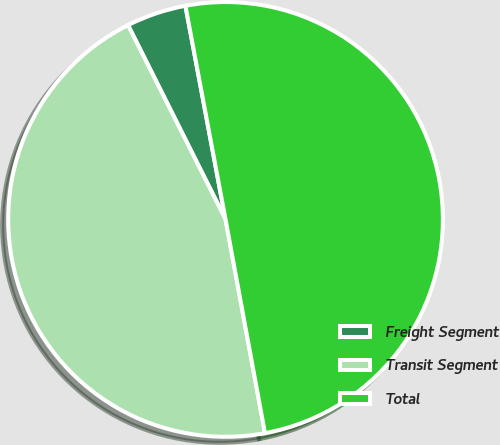<chart> <loc_0><loc_0><loc_500><loc_500><pie_chart><fcel>Freight Segment<fcel>Transit Segment<fcel>Total<nl><fcel>4.45%<fcel>45.5%<fcel>50.05%<nl></chart> 